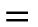<formula> <loc_0><loc_0><loc_500><loc_500>\begin{matrix} = \end{matrix}</formula> 